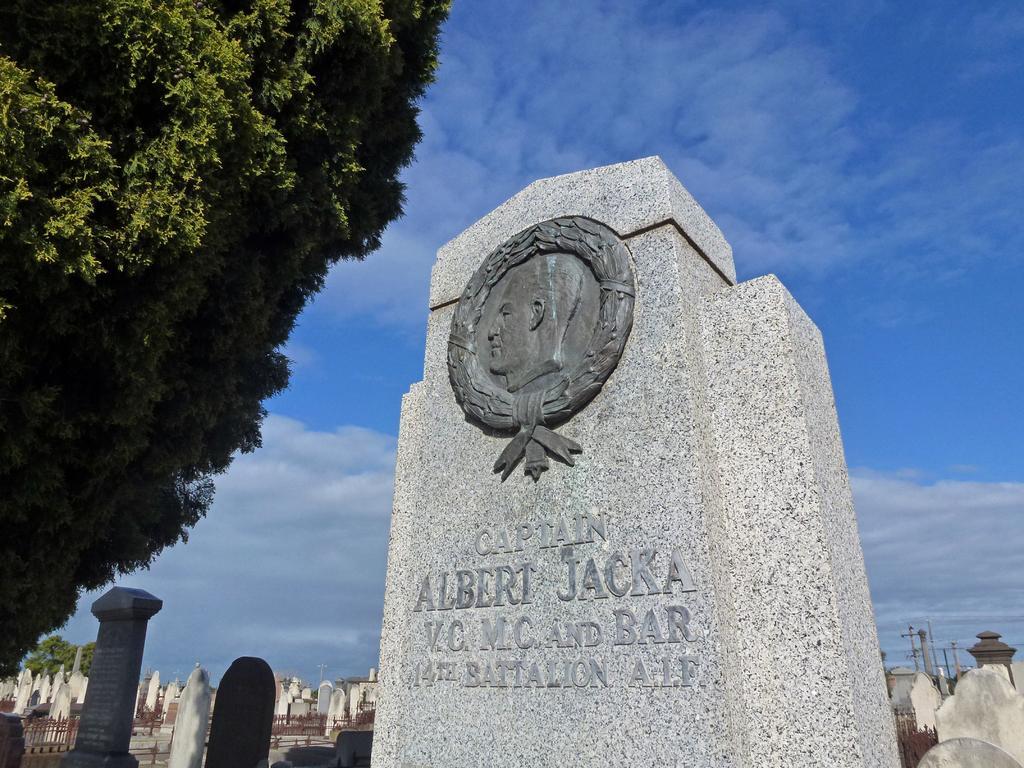Could you give a brief overview of what you see in this image? In this image I can see number of tombstones and in the front I can see something is written on the stone. On the left side of this image I can see few trees and in the background I can see clouds and the sky. 